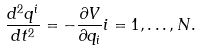<formula> <loc_0><loc_0><loc_500><loc_500>\frac { d ^ { 2 } q ^ { i } } { d t ^ { 2 } } = - \frac { \partial V } { \partial q _ { i } } i = 1 , \dots , N .</formula> 